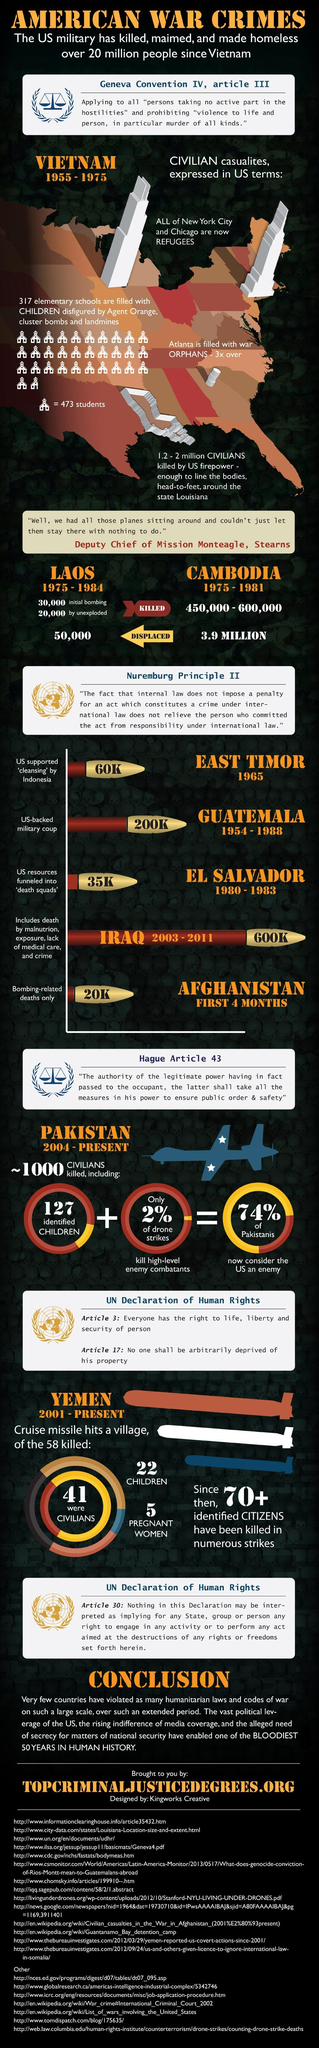Draw attention to some important aspects in this diagram. During the period of 1975-1981 in Cambodia, an estimated 450,000 to 600,000 people were killed. During the period of 1975-1981, an estimated 3.9 million people fled from Cambodia. 